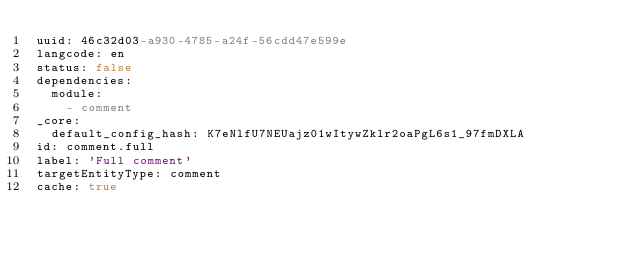<code> <loc_0><loc_0><loc_500><loc_500><_YAML_>uuid: 46c32d03-a930-4785-a24f-56cdd47e599e
langcode: en
status: false
dependencies:
  module:
    - comment
_core:
  default_config_hash: K7eNlfU7NEUajz01wItywZklr2oaPgL6s1_97fmDXLA
id: comment.full
label: 'Full comment'
targetEntityType: comment
cache: true
</code> 